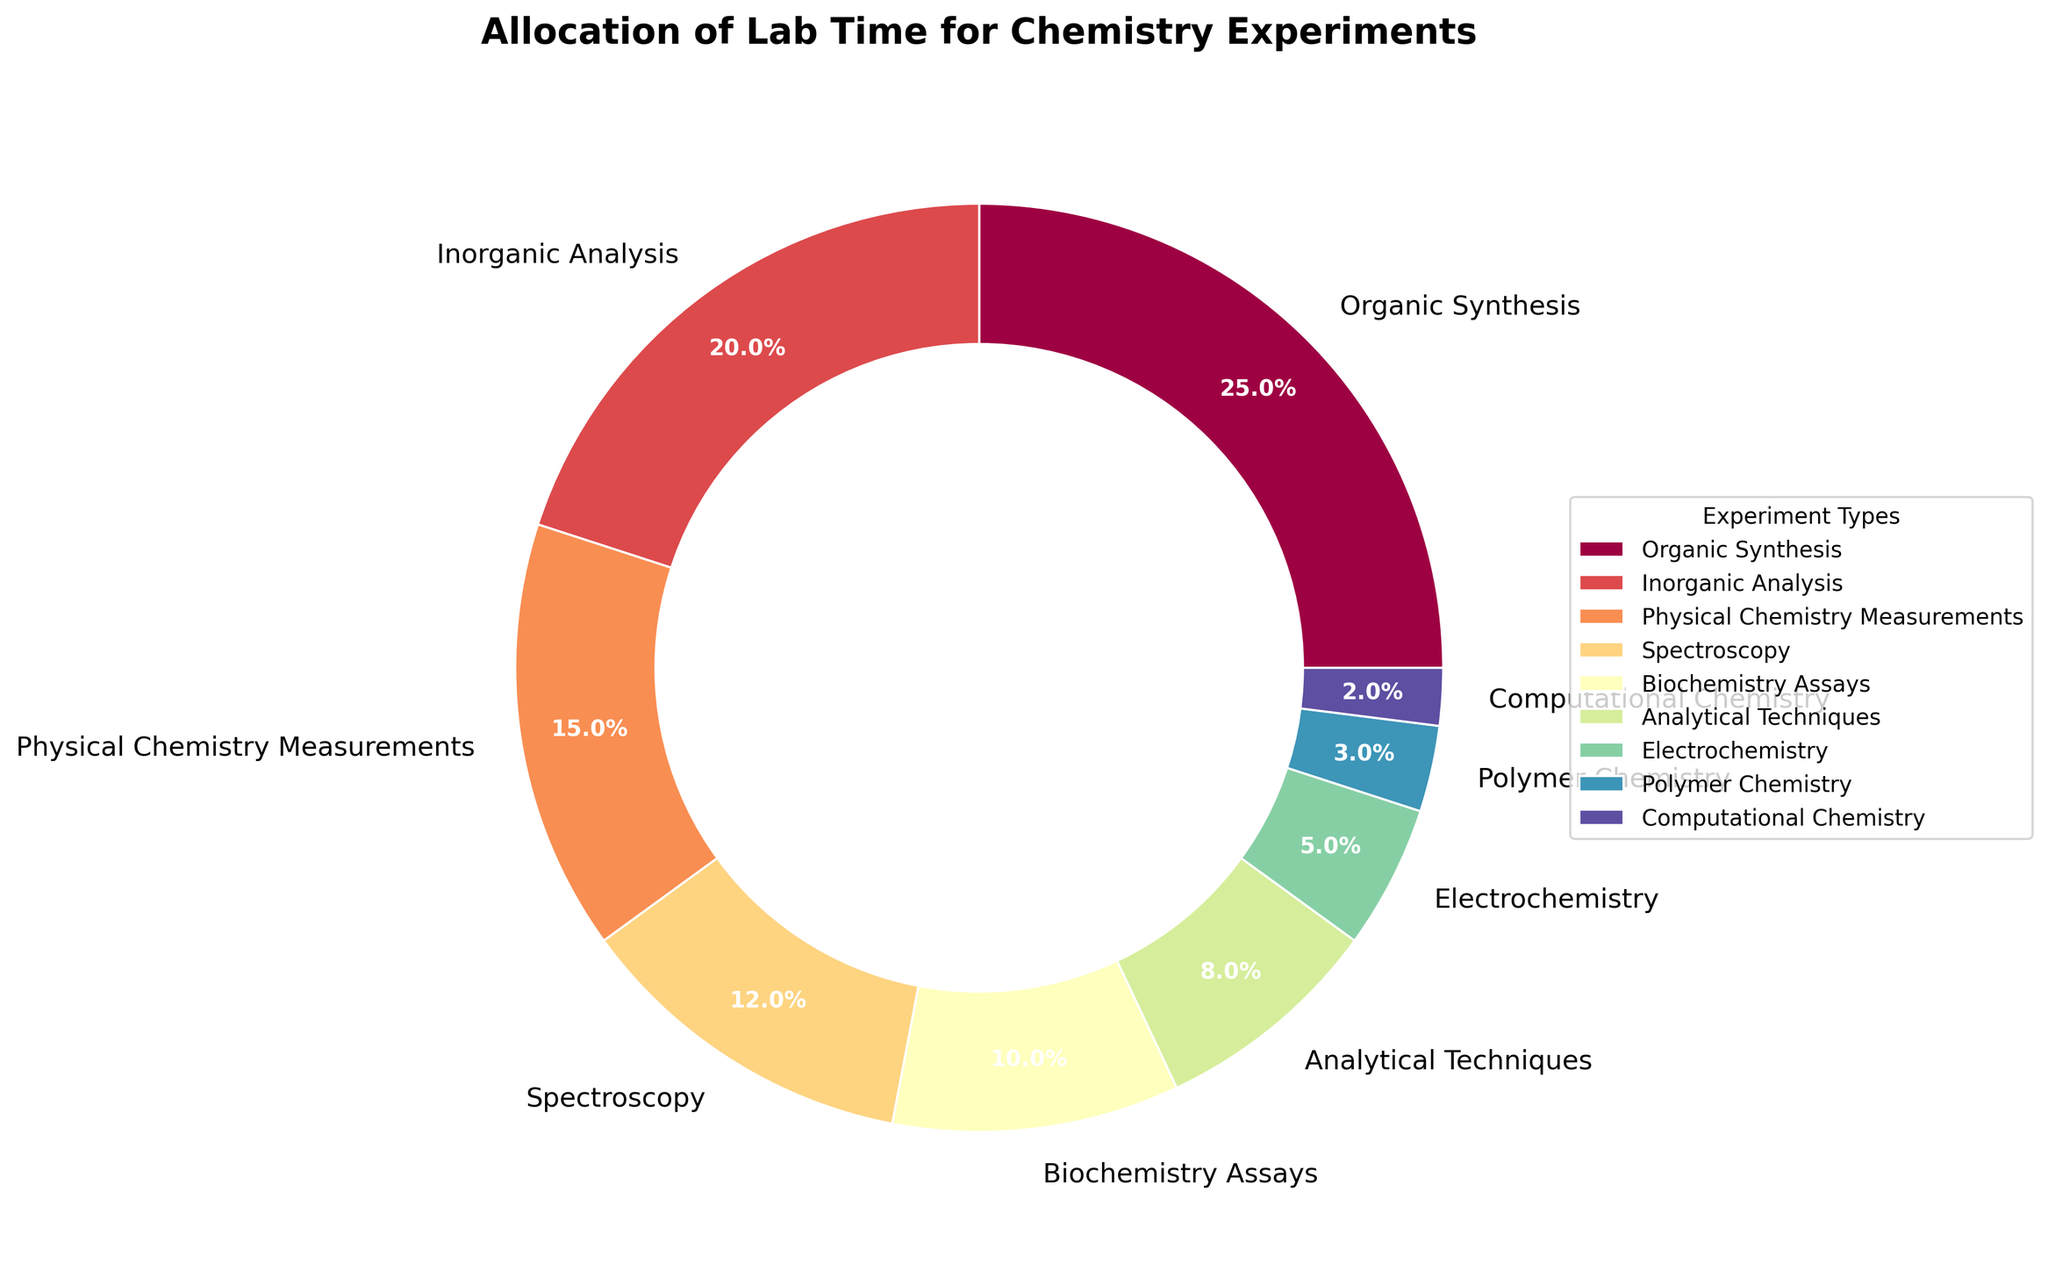Which experiment type takes up the largest allocation of lab time? The pie chart shows the different percentages for each experiment type. Organic Synthesis has the highest percentage.
Answer: Organic Synthesis How much more lab time is allocated to Organic Synthesis compared to Electrochemistry? The figure shows that Organic Synthesis has 25% and Electrochemistry has 5%. The difference is 25% - 5%.
Answer: 20% Which experiment type is allocated the least amount of lab time? The smallest portion in the pie chart represents Computational Chemistry with 2%.
Answer: Computational Chemistry How does the lab time allocated to Physical Chemistry Measurements compare to that for Spectroscopy? Physical Chemistry Measurements is 15% and Spectroscopy is 12%, so Physical Chemistry Measurements has 3% more lab time.
Answer: Physical Chemistry Measurements has 3% more What is the total lab time percentage allocated to Analytical Techniques and Polymer Chemistry combined? The chart shows Analytical Techniques with 8% and Polymer Chemistry with 3%. Adding them together gives 8% + 3%.
Answer: 11% Is the lab time allocated to Biochemistry Assays more than twice that allocated to Computational Chemistry? Biochemistry Assays is 10% and Computational Chemistry is 2%. 10% is indeed more than twice 2%.
Answer: Yes What is the combined lab time allocation for Inorganic Analysis and Electrochemistry? Inorganic Analysis is 20% and Electrochemistry is 5%. Adding them together, 20% + 5% = 25%.
Answer: 25% Which two experiment types together make up exactly one-third of the lab time allocation? One-third of 100% is approximately 33.33%. Adding Analytical Techniques (8%) and Inorganic Analysis (20%) and Polymer Chemistry (3%) gives 8% + 20% + 3% = 31%, none exactly add to 33.33%.
Answer: None How many percentage points less lab time is allocated to Biochemistry Assays compared to Organic Synthesis? Organic Synthesis is 25% and Biochemistry Assays is 10%. The difference is 25% - 10%.
Answer: 15% If the lab time for Spectroscopy were to double, what would be its new percentage allocation? Spectroscopy currently has 12%. Doubling it would result in 12% * 2.
Answer: 24% 